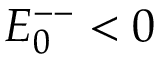<formula> <loc_0><loc_0><loc_500><loc_500>E _ { 0 } ^ { - - } < 0</formula> 